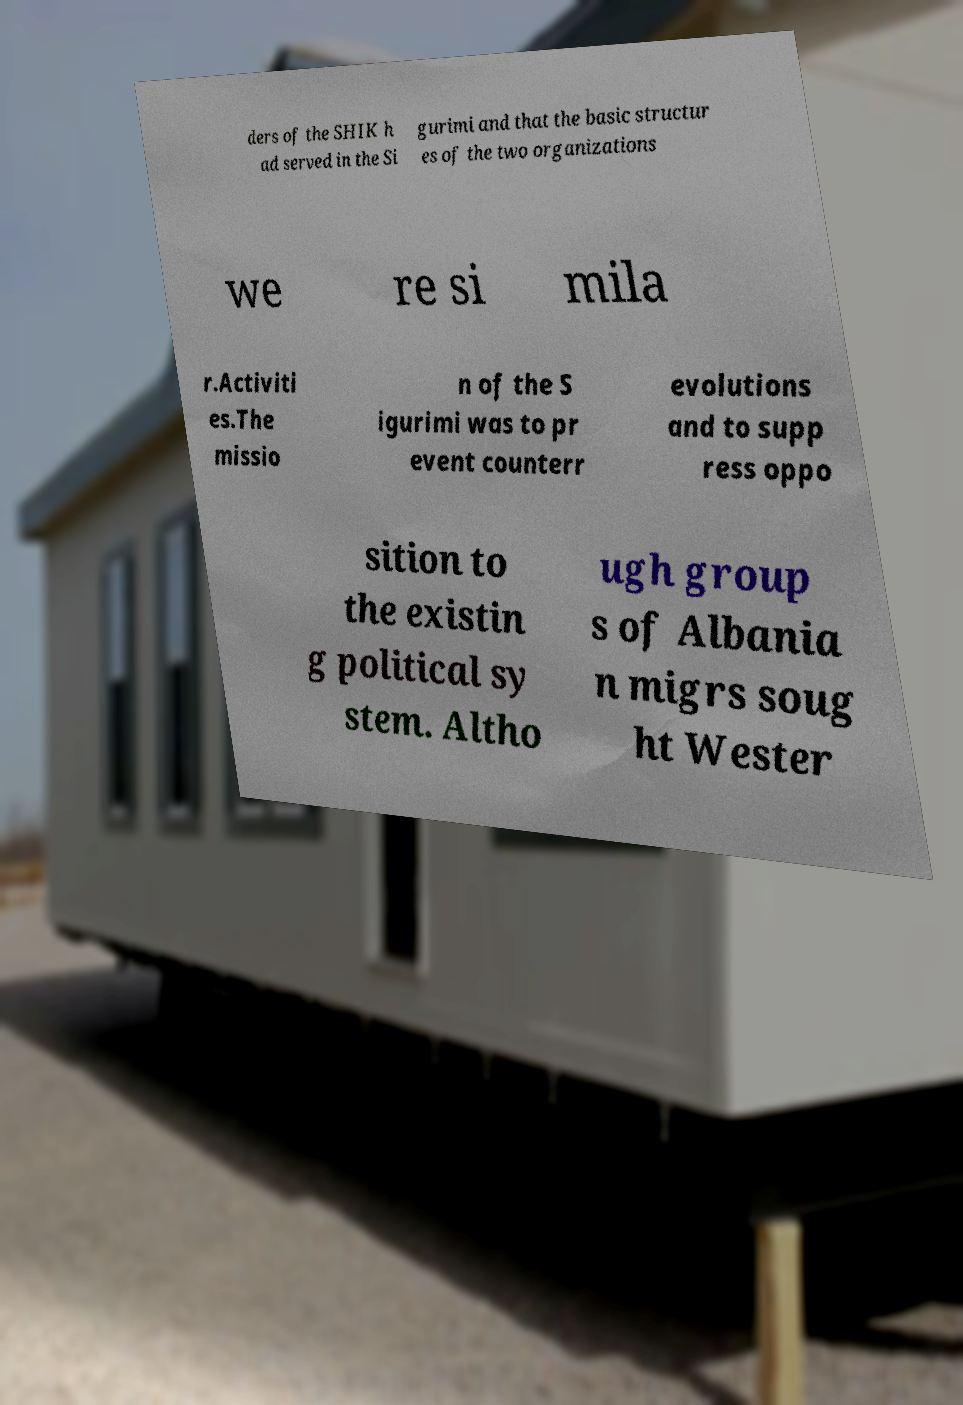Please identify and transcribe the text found in this image. ders of the SHIK h ad served in the Si gurimi and that the basic structur es of the two organizations we re si mila r.Activiti es.The missio n of the S igurimi was to pr event counterr evolutions and to supp ress oppo sition to the existin g political sy stem. Altho ugh group s of Albania n migrs soug ht Wester 